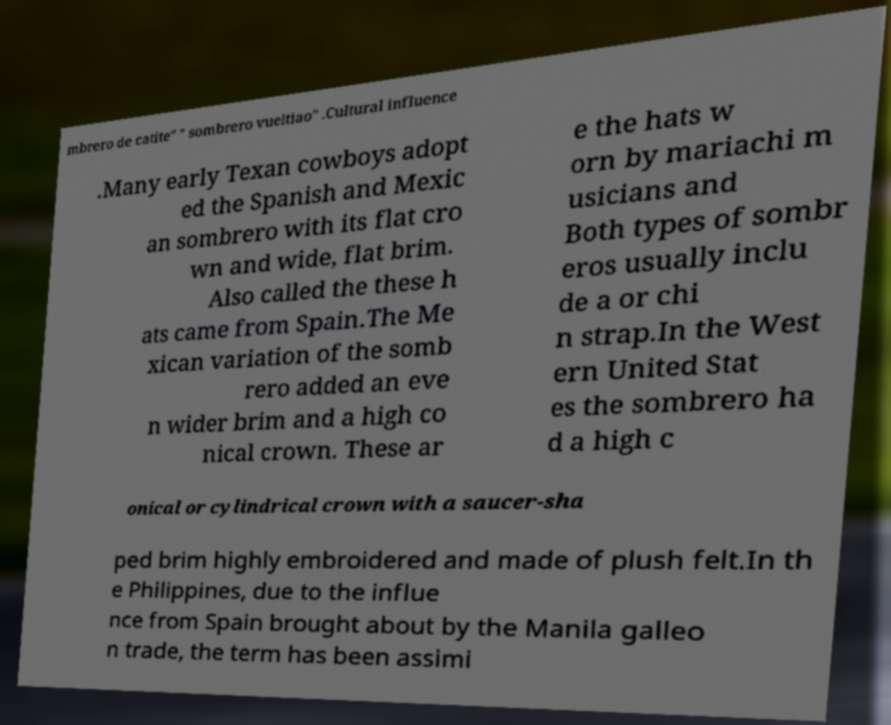For documentation purposes, I need the text within this image transcribed. Could you provide that? mbrero de catite" " sombrero vueltiao" .Cultural influence .Many early Texan cowboys adopt ed the Spanish and Mexic an sombrero with its flat cro wn and wide, flat brim. Also called the these h ats came from Spain.The Me xican variation of the somb rero added an eve n wider brim and a high co nical crown. These ar e the hats w orn by mariachi m usicians and Both types of sombr eros usually inclu de a or chi n strap.In the West ern United Stat es the sombrero ha d a high c onical or cylindrical crown with a saucer-sha ped brim highly embroidered and made of plush felt.In th e Philippines, due to the influe nce from Spain brought about by the Manila galleo n trade, the term has been assimi 